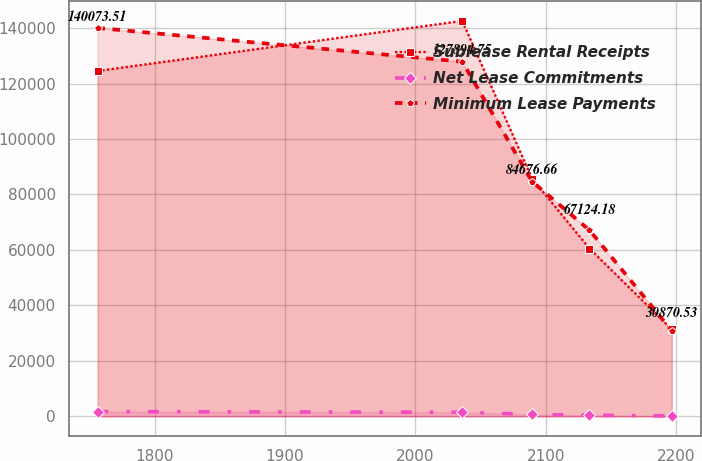Convert chart. <chart><loc_0><loc_0><loc_500><loc_500><line_chart><ecel><fcel>Sublease Rental Receipts<fcel>Net Lease Commitments<fcel>Minimum Lease Payments<nl><fcel>1756.09<fcel>124539<fcel>1701.73<fcel>140074<nl><fcel>2035.99<fcel>142614<fcel>1453.4<fcel>127895<nl><fcel>2089.58<fcel>85752.6<fcel>653.85<fcel>84676.7<nl><fcel>2133.65<fcel>60506.4<fcel>378.27<fcel>67124.2<nl><fcel>2196.83<fcel>31307.2<fcel>109.4<fcel>30870.5<nl></chart> 